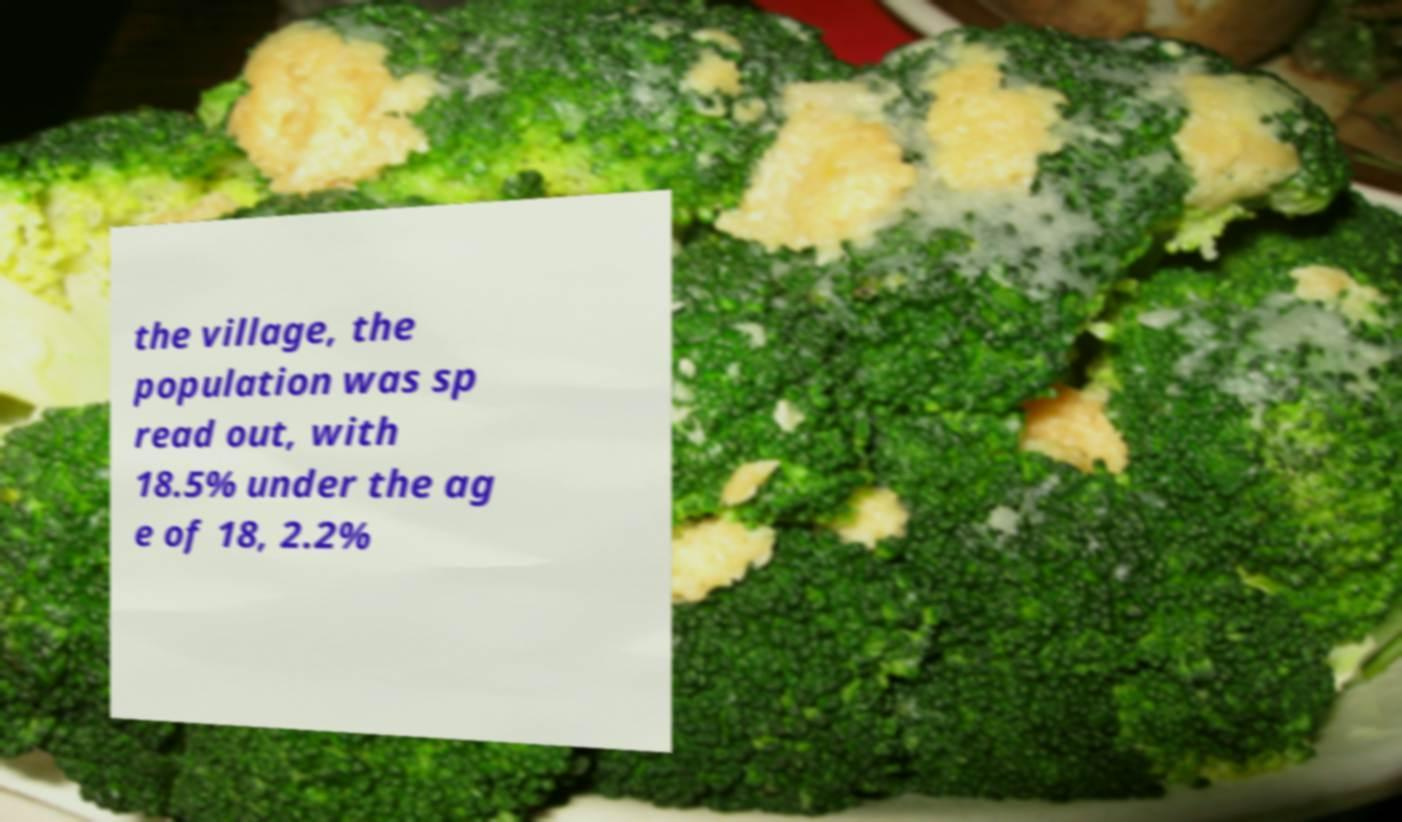Could you extract and type out the text from this image? the village, the population was sp read out, with 18.5% under the ag e of 18, 2.2% 